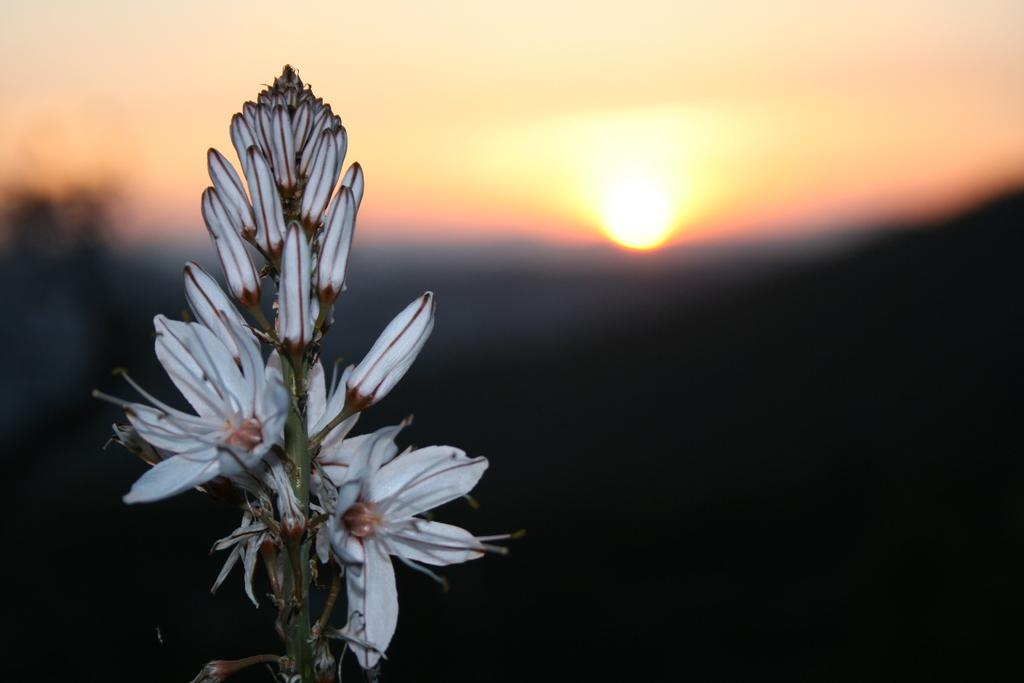What type of plant life is visible in the image? There are flowers, buds, and stems in the image. Can you describe the stage of growth for the plants in the image? The plants in the image have buds, which suggests they are in the early stages of growth. What is the condition of the background in the image? The background of the image is blurry. Who is the owner of the jam in the image? There is no jam present in the image, so it is not possible to determine the owner. 